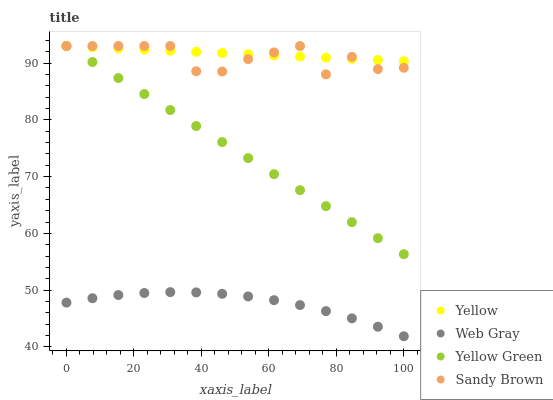Does Web Gray have the minimum area under the curve?
Answer yes or no. Yes. Does Yellow have the maximum area under the curve?
Answer yes or no. Yes. Does Sandy Brown have the minimum area under the curve?
Answer yes or no. No. Does Sandy Brown have the maximum area under the curve?
Answer yes or no. No. Is Yellow Green the smoothest?
Answer yes or no. Yes. Is Sandy Brown the roughest?
Answer yes or no. Yes. Is Sandy Brown the smoothest?
Answer yes or no. No. Is Yellow Green the roughest?
Answer yes or no. No. Does Web Gray have the lowest value?
Answer yes or no. Yes. Does Sandy Brown have the lowest value?
Answer yes or no. No. Does Yellow have the highest value?
Answer yes or no. Yes. Is Web Gray less than Yellow?
Answer yes or no. Yes. Is Sandy Brown greater than Web Gray?
Answer yes or no. Yes. Does Sandy Brown intersect Yellow?
Answer yes or no. Yes. Is Sandy Brown less than Yellow?
Answer yes or no. No. Is Sandy Brown greater than Yellow?
Answer yes or no. No. Does Web Gray intersect Yellow?
Answer yes or no. No. 